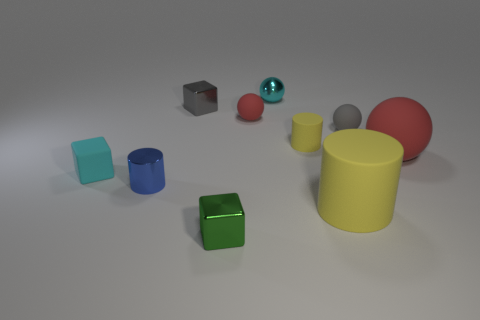Subtract all tiny cyan balls. How many balls are left? 3 Subtract 1 spheres. How many spheres are left? 3 Subtract all cyan balls. How many yellow cylinders are left? 2 Subtract all cyan balls. How many balls are left? 3 Subtract all balls. How many objects are left? 6 Subtract all brown balls. Subtract all brown cylinders. How many balls are left? 4 Subtract all small yellow cylinders. Subtract all small matte things. How many objects are left? 5 Add 2 rubber cubes. How many rubber cubes are left? 3 Add 4 green blocks. How many green blocks exist? 5 Subtract 0 blue balls. How many objects are left? 10 